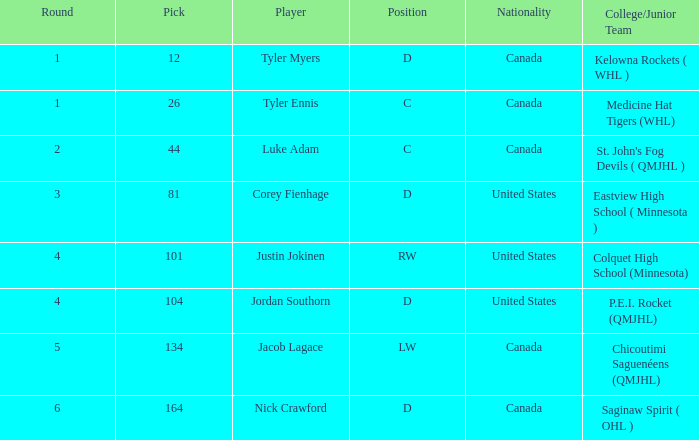What is the average round of the rw position player from the United States? 4.0. 